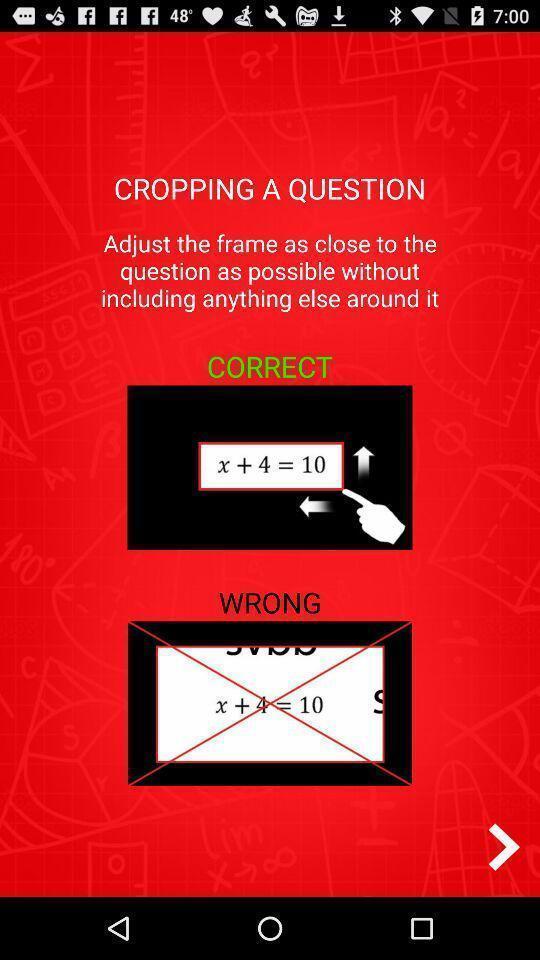Describe the visual elements of this screenshot. Screen showing instruction for cropping. 